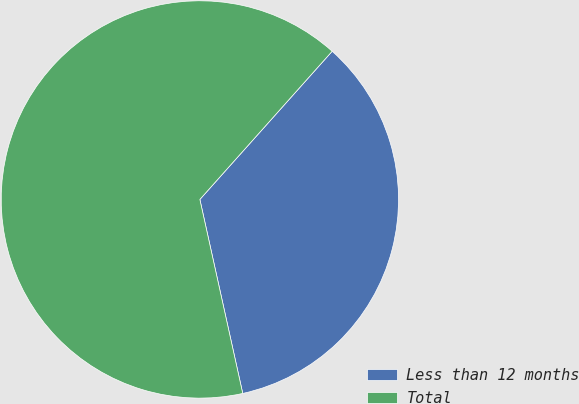Convert chart to OTSL. <chart><loc_0><loc_0><loc_500><loc_500><pie_chart><fcel>Less than 12 months<fcel>Total<nl><fcel>34.94%<fcel>65.06%<nl></chart> 